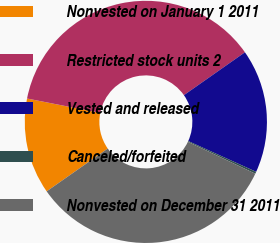Convert chart. <chart><loc_0><loc_0><loc_500><loc_500><pie_chart><fcel>Nonvested on January 1 2011<fcel>Restricted stock units 2<fcel>Vested and released<fcel>Canceled/forfeited<fcel>Nonvested on December 31 2011<nl><fcel>12.82%<fcel>37.16%<fcel>16.51%<fcel>0.27%<fcel>33.24%<nl></chart> 